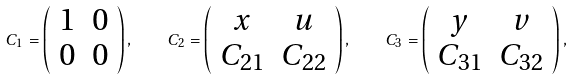Convert formula to latex. <formula><loc_0><loc_0><loc_500><loc_500>C _ { 1 } = \left ( \begin{array} { c c } 1 & 0 \\ 0 & 0 \end{array} \right ) , \quad C _ { 2 } = \left ( \begin{array} { c c } x & u \\ C _ { 2 1 } & C _ { 2 2 } \end{array} \right ) , \quad C _ { 3 } = \left ( \begin{array} { c c } y & v \\ C _ { 3 1 } & C _ { 3 2 } \end{array} \right ) ,</formula> 